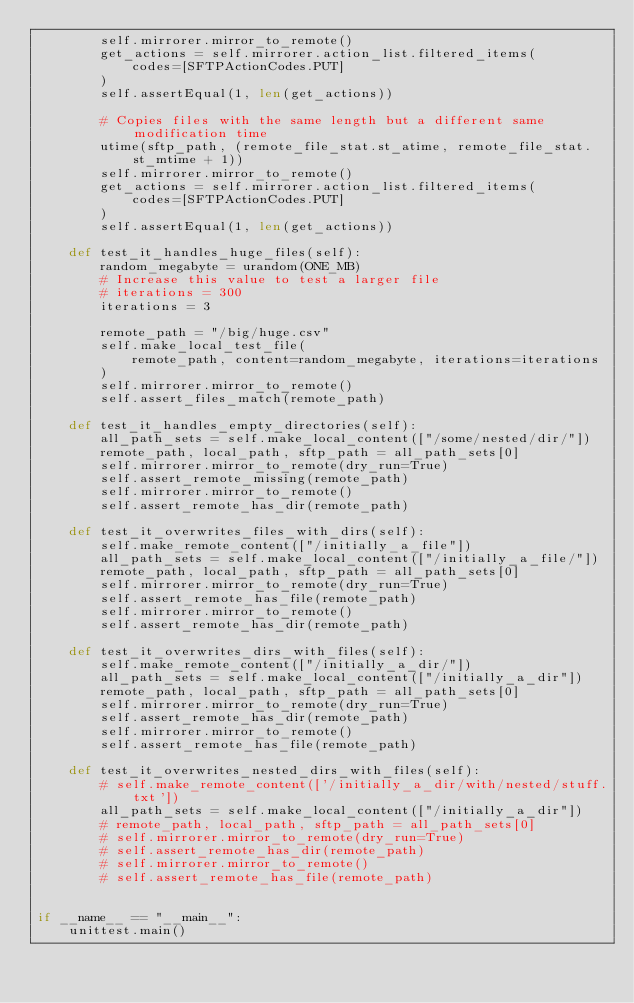<code> <loc_0><loc_0><loc_500><loc_500><_Python_>        self.mirrorer.mirror_to_remote()
        get_actions = self.mirrorer.action_list.filtered_items(
            codes=[SFTPActionCodes.PUT]
        )
        self.assertEqual(1, len(get_actions))

        # Copies files with the same length but a different same modification time
        utime(sftp_path, (remote_file_stat.st_atime, remote_file_stat.st_mtime + 1))
        self.mirrorer.mirror_to_remote()
        get_actions = self.mirrorer.action_list.filtered_items(
            codes=[SFTPActionCodes.PUT]
        )
        self.assertEqual(1, len(get_actions))

    def test_it_handles_huge_files(self):
        random_megabyte = urandom(ONE_MB)
        # Increase this value to test a larger file
        # iterations = 300
        iterations = 3

        remote_path = "/big/huge.csv"
        self.make_local_test_file(
            remote_path, content=random_megabyte, iterations=iterations
        )
        self.mirrorer.mirror_to_remote()
        self.assert_files_match(remote_path)

    def test_it_handles_empty_directories(self):
        all_path_sets = self.make_local_content(["/some/nested/dir/"])
        remote_path, local_path, sftp_path = all_path_sets[0]
        self.mirrorer.mirror_to_remote(dry_run=True)
        self.assert_remote_missing(remote_path)
        self.mirrorer.mirror_to_remote()
        self.assert_remote_has_dir(remote_path)

    def test_it_overwrites_files_with_dirs(self):
        self.make_remote_content(["/initially_a_file"])
        all_path_sets = self.make_local_content(["/initially_a_file/"])
        remote_path, local_path, sftp_path = all_path_sets[0]
        self.mirrorer.mirror_to_remote(dry_run=True)
        self.assert_remote_has_file(remote_path)
        self.mirrorer.mirror_to_remote()
        self.assert_remote_has_dir(remote_path)

    def test_it_overwrites_dirs_with_files(self):
        self.make_remote_content(["/initially_a_dir/"])
        all_path_sets = self.make_local_content(["/initially_a_dir"])
        remote_path, local_path, sftp_path = all_path_sets[0]
        self.mirrorer.mirror_to_remote(dry_run=True)
        self.assert_remote_has_dir(remote_path)
        self.mirrorer.mirror_to_remote()
        self.assert_remote_has_file(remote_path)

    def test_it_overwrites_nested_dirs_with_files(self):
        # self.make_remote_content(['/initially_a_dir/with/nested/stuff.txt'])
        all_path_sets = self.make_local_content(["/initially_a_dir"])
        # remote_path, local_path, sftp_path = all_path_sets[0]
        # self.mirrorer.mirror_to_remote(dry_run=True)
        # self.assert_remote_has_dir(remote_path)
        # self.mirrorer.mirror_to_remote()
        # self.assert_remote_has_file(remote_path)


if __name__ == "__main__":
    unittest.main()
</code> 